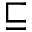<formula> <loc_0><loc_0><loc_500><loc_500>\sqsubseteq</formula> 